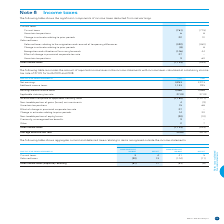According to Bce's financial document, What does the table show? the significant components of income taxes deducted from net earnings. The document states: "The following table shows the significant components of income taxes deducted from net earnings...." Also, What is the amount for change in estimate relating to prior periods for current taxes in 2019? According to the financial document, 22. The relevant text states: "Change in estimate relating to prior periods 22 12..." Also, What is the amount for uncertain tax positions for current taxes in 2019? According to the financial document, 6. The relevant text states: "Current taxes (761) (775)..." Also, How many components of current taxes are there? Counting the relevant items in the document: Current taxes, uncertain tax positions, change in estimate relating to prior periods, I find 3 instances. The key data points involved are: Current taxes, change in estimate relating to prior periods, uncertain tax positions. Also, can you calculate: What is the total amount of uncertain tax positions for 2019? Based on the calculation: 6+9, the result is 15. This is based on the information: "Uncertain tax positions 9 60 Uncertain tax positions 9 60..." The key data points involved are: 6, 9. Also, can you calculate: What is the change in the change in estimate relating to prior periods for current taxes? Based on the calculation: 22-12, the result is 10. This is based on the information: "Change in estimate relating to prior periods 22 12 Change in estimate relating to prior periods 22 12..." The key data points involved are: 12, 22. 